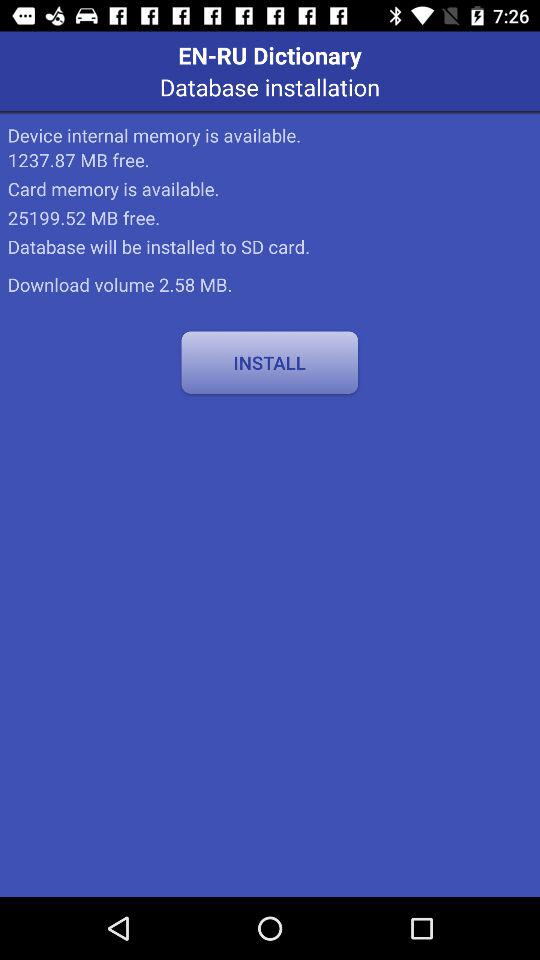In a card, how much free memory is available? The free memory available on a card is 25199.52 MB. 